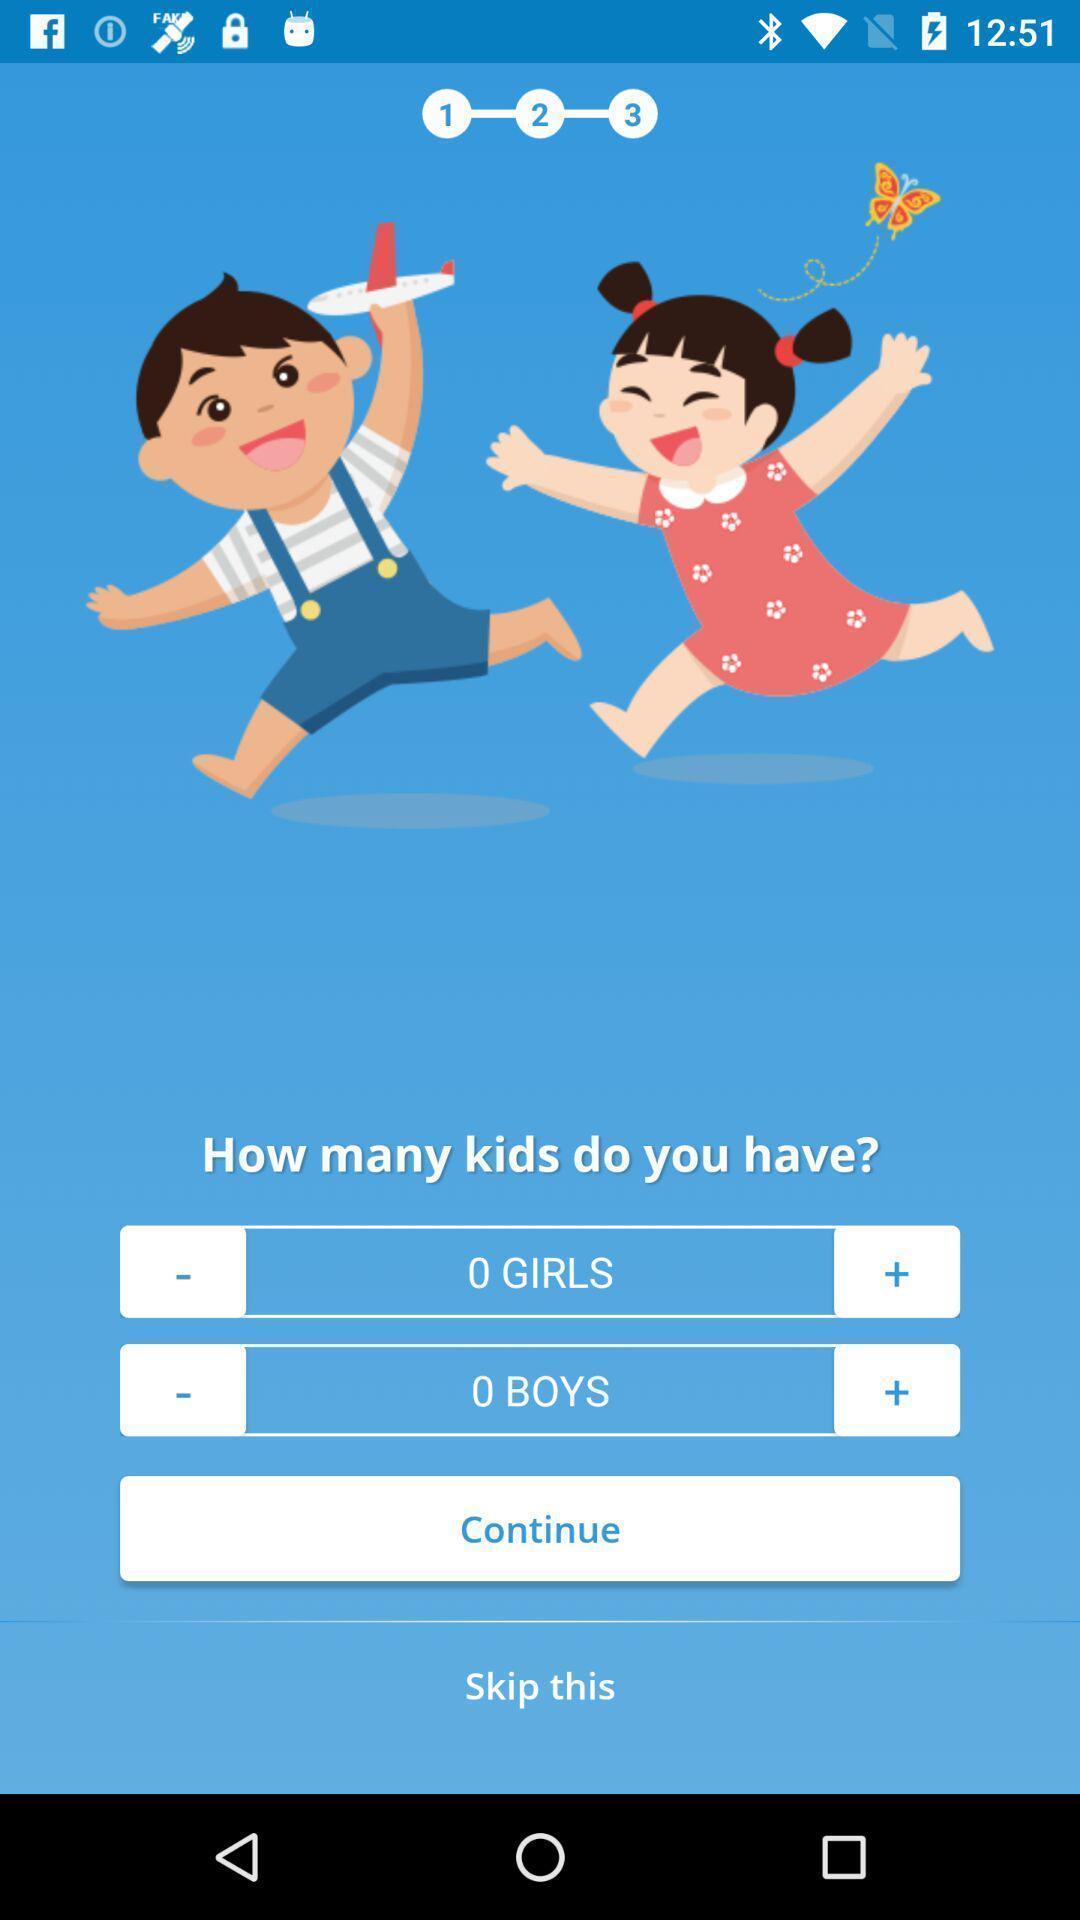What details can you identify in this image? Page with options. 